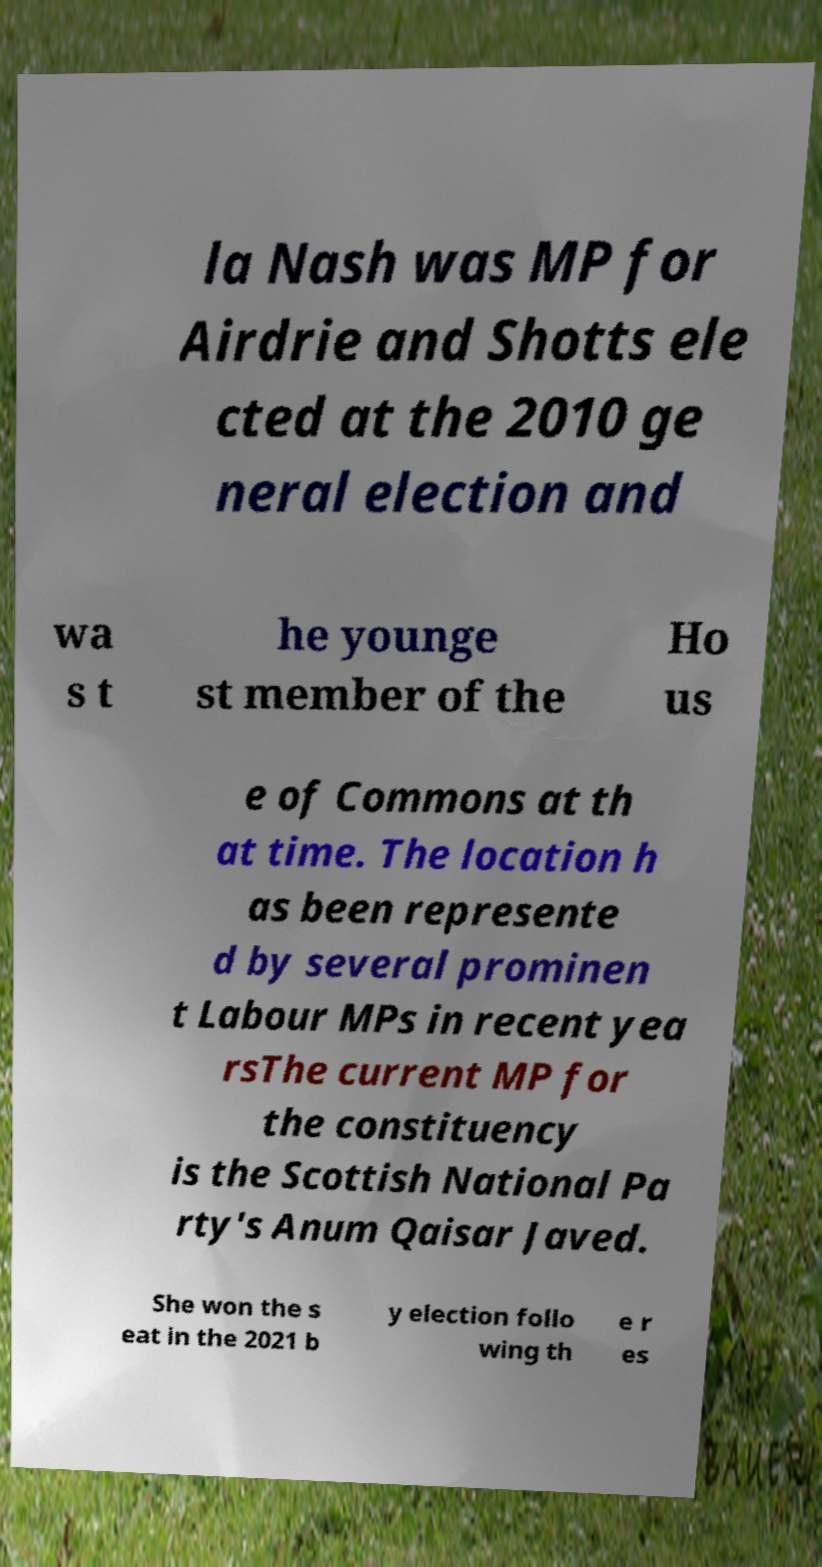I need the written content from this picture converted into text. Can you do that? la Nash was MP for Airdrie and Shotts ele cted at the 2010 ge neral election and wa s t he younge st member of the Ho us e of Commons at th at time. The location h as been represente d by several prominen t Labour MPs in recent yea rsThe current MP for the constituency is the Scottish National Pa rty's Anum Qaisar Javed. She won the s eat in the 2021 b y election follo wing th e r es 